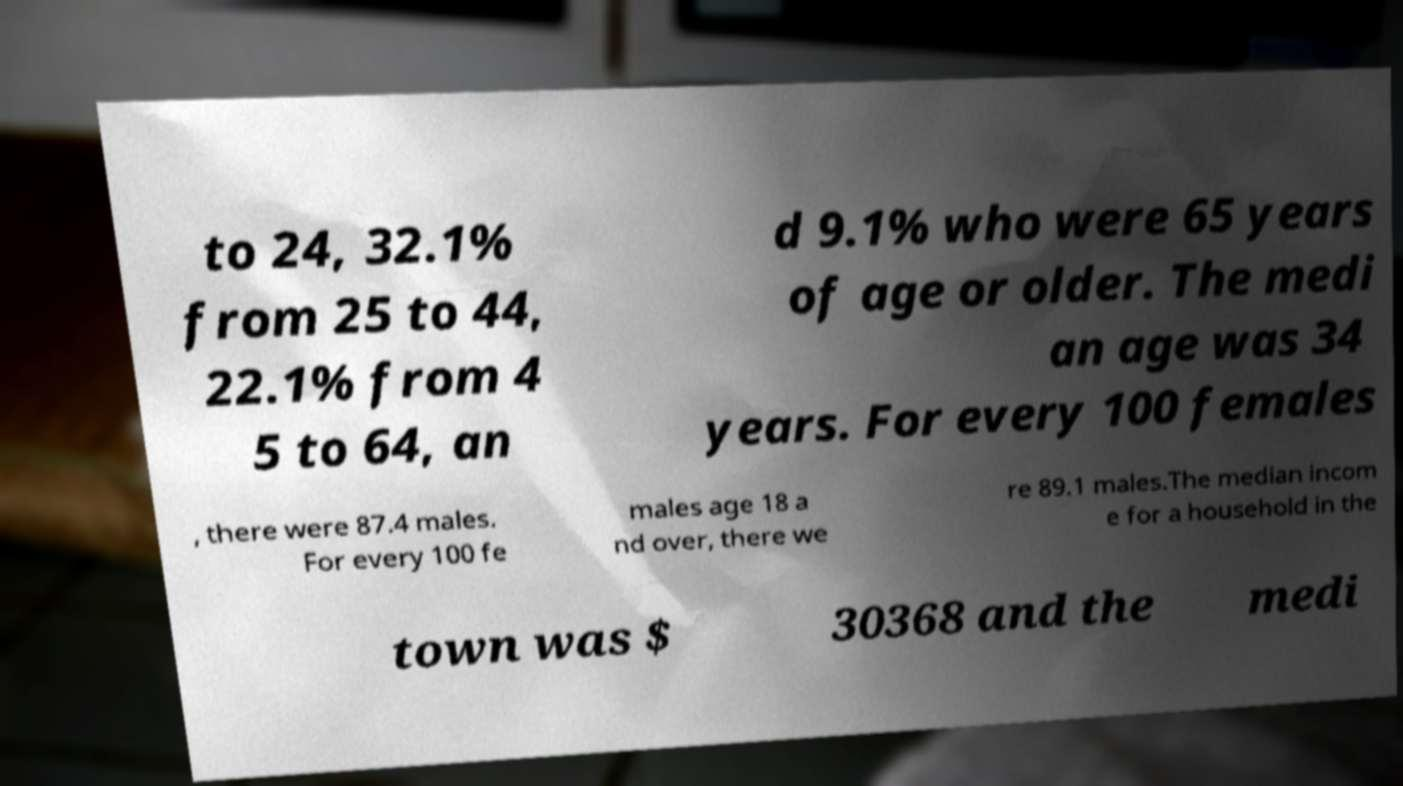There's text embedded in this image that I need extracted. Can you transcribe it verbatim? to 24, 32.1% from 25 to 44, 22.1% from 4 5 to 64, an d 9.1% who were 65 years of age or older. The medi an age was 34 years. For every 100 females , there were 87.4 males. For every 100 fe males age 18 a nd over, there we re 89.1 males.The median incom e for a household in the town was $ 30368 and the medi 